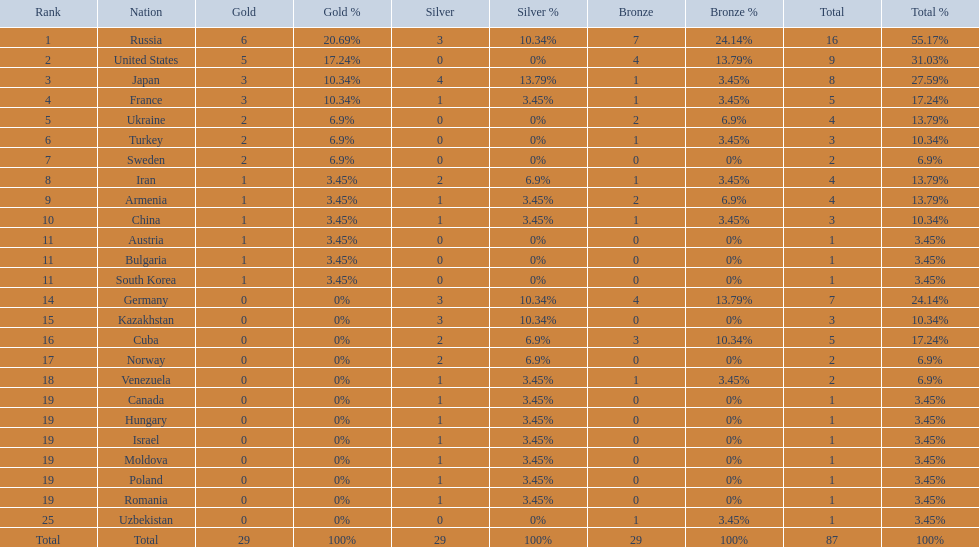Which country won only one medal, a bronze medal? Uzbekistan. Would you be able to parse every entry in this table? {'header': ['Rank', 'Nation', 'Gold', 'Gold %', 'Silver', 'Silver %', 'Bronze', 'Bronze %', 'Total', 'Total %'], 'rows': [['1', 'Russia', '6', '20.69%', '3', '10.34%', '7', '24.14%', '16', '55.17%'], ['2', 'United States', '5', '17.24%', '0', '0%', '4', '13.79%', '9', '31.03%'], ['3', 'Japan', '3', '10.34%', '4', '13.79%', '1', '3.45%', '8', '27.59%'], ['4', 'France', '3', '10.34%', '1', '3.45%', '1', '3.45%', '5', '17.24%'], ['5', 'Ukraine', '2', '6.9%', '0', '0%', '2', '6.9%', '4', '13.79%'], ['6', 'Turkey', '2', '6.9%', '0', '0%', '1', '3.45%', '3', '10.34%'], ['7', 'Sweden', '2', '6.9%', '0', '0%', '0', '0%', '2', '6.9%'], ['8', 'Iran', '1', '3.45%', '2', '6.9%', '1', '3.45%', '4', '13.79%'], ['9', 'Armenia', '1', '3.45%', '1', '3.45%', '2', '6.9%', '4', '13.79%'], ['10', 'China', '1', '3.45%', '1', '3.45%', '1', '3.45%', '3', '10.34%'], ['11', 'Austria', '1', '3.45%', '0', '0%', '0', '0%', '1', '3.45%'], ['11', 'Bulgaria', '1', '3.45%', '0', '0%', '0', '0%', '1', '3.45%'], ['11', 'South Korea', '1', '3.45%', '0', '0%', '0', '0%', '1', '3.45%'], ['14', 'Germany', '0', '0%', '3', '10.34%', '4', '13.79%', '7', '24.14%'], ['15', 'Kazakhstan', '0', '0%', '3', '10.34%', '0', '0%', '3', '10.34%'], ['16', 'Cuba', '0', '0%', '2', '6.9%', '3', '10.34%', '5', '17.24%'], ['17', 'Norway', '0', '0%', '2', '6.9%', '0', '0%', '2', '6.9%'], ['18', 'Venezuela', '0', '0%', '1', '3.45%', '1', '3.45%', '2', '6.9%'], ['19', 'Canada', '0', '0%', '1', '3.45%', '0', '0%', '1', '3.45%'], ['19', 'Hungary', '0', '0%', '1', '3.45%', '0', '0%', '1', '3.45%'], ['19', 'Israel', '0', '0%', '1', '3.45%', '0', '0%', '1', '3.45%'], ['19', 'Moldova', '0', '0%', '1', '3.45%', '0', '0%', '1', '3.45%'], ['19', 'Poland', '0', '0%', '1', '3.45%', '0', '0%', '1', '3.45%'], ['19', 'Romania', '0', '0%', '1', '3.45%', '0', '0%', '1', '3.45%'], ['25', 'Uzbekistan', '0', '0%', '0', '0%', '1', '3.45%', '1', '3.45%'], ['Total', 'Total', '29', '100%', '29', '100%', '29', '100%', '87', '100%']]} 